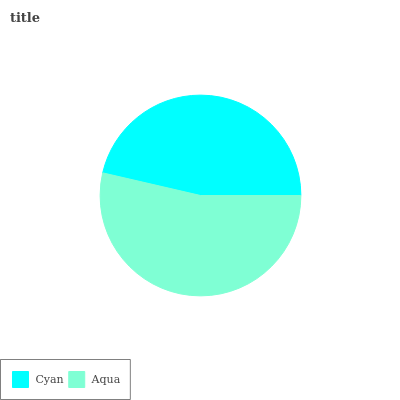Is Cyan the minimum?
Answer yes or no. Yes. Is Aqua the maximum?
Answer yes or no. Yes. Is Aqua the minimum?
Answer yes or no. No. Is Aqua greater than Cyan?
Answer yes or no. Yes. Is Cyan less than Aqua?
Answer yes or no. Yes. Is Cyan greater than Aqua?
Answer yes or no. No. Is Aqua less than Cyan?
Answer yes or no. No. Is Aqua the high median?
Answer yes or no. Yes. Is Cyan the low median?
Answer yes or no. Yes. Is Cyan the high median?
Answer yes or no. No. Is Aqua the low median?
Answer yes or no. No. 